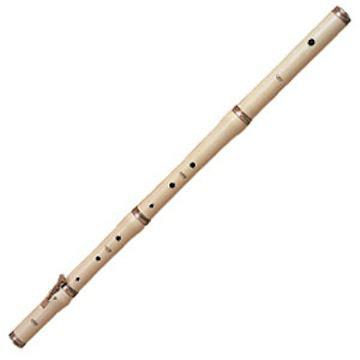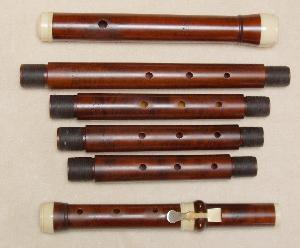The first image is the image on the left, the second image is the image on the right. Given the left and right images, does the statement "There are two musical instruments." hold true? Answer yes or no. No. The first image is the image on the left, the second image is the image on the right. For the images displayed, is the sentence "The left and right images do not contain the same number of items, but the combined images include at least four items of the same color." factually correct? Answer yes or no. Yes. 